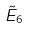Convert formula to latex. <formula><loc_0><loc_0><loc_500><loc_500>\tilde { E } _ { 6 }</formula> 